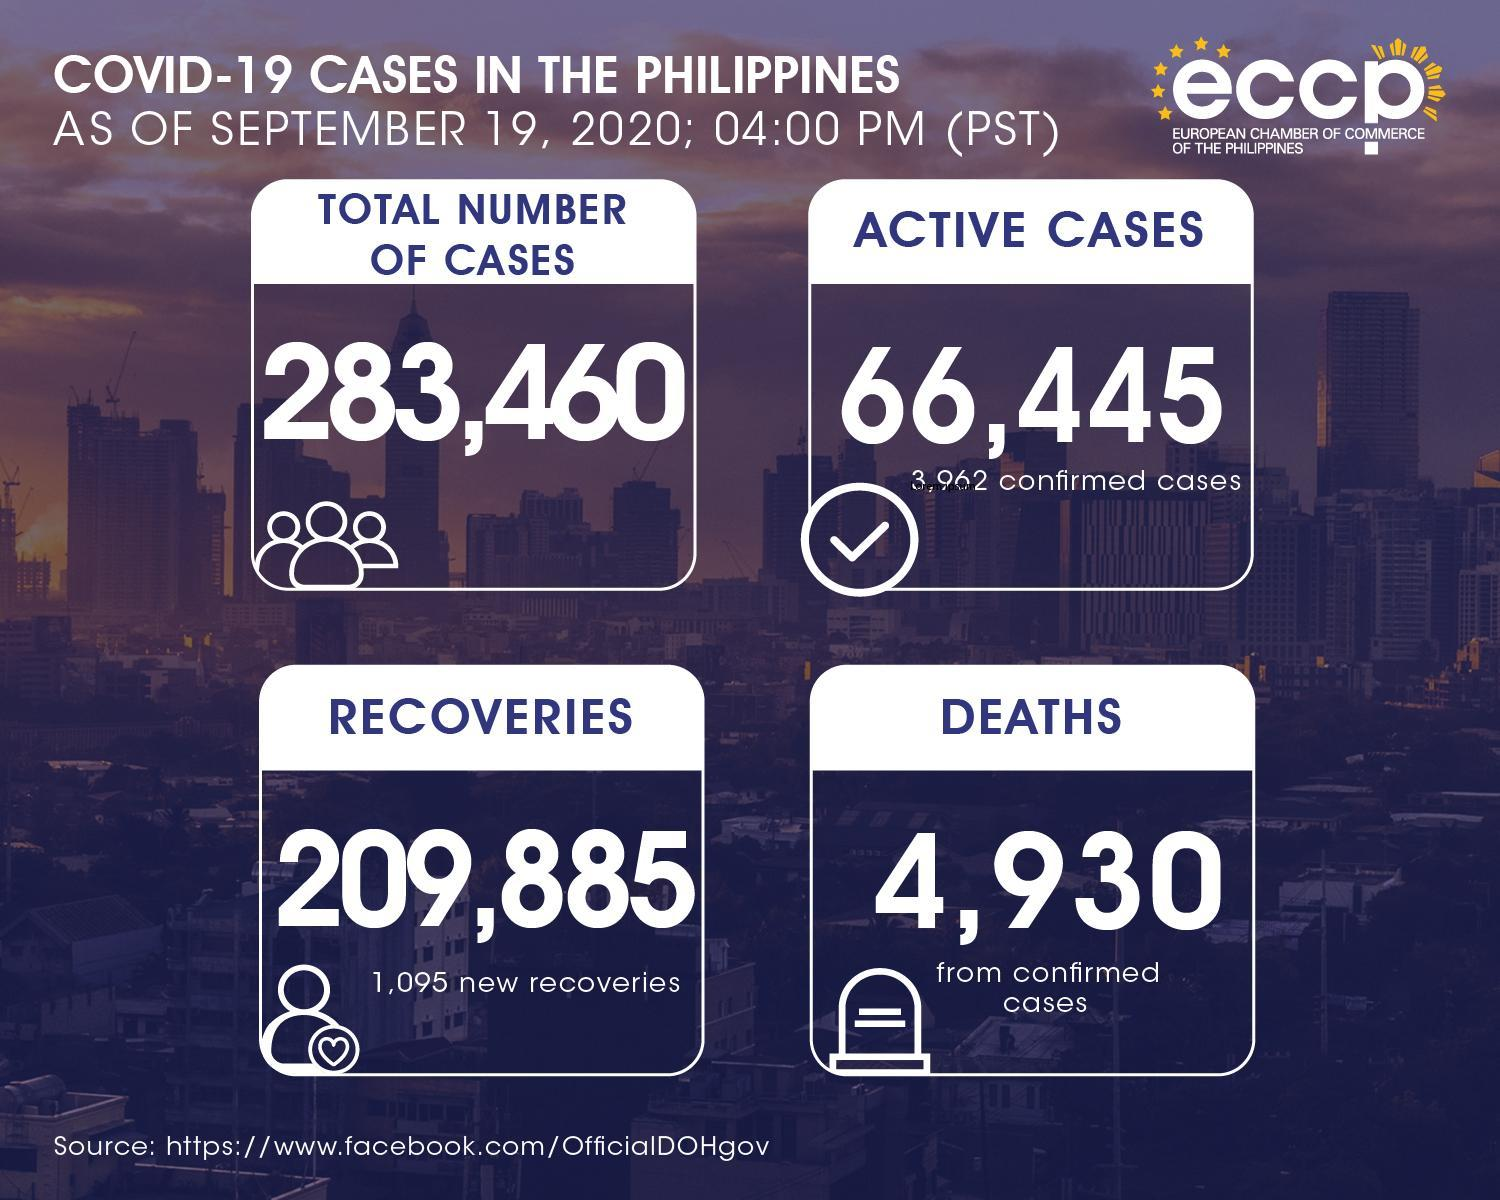What is the number of new recoveries from COVID-19 in the Phillippines as of september 19, 2020?
Answer the question with a short phrase. 1,095 What is the total number of COVID-19 cases in the Phillippines as of september 19, 2020? 283,460 What is the total number of COVID-19 deaths in the Phillippines as of september 19, 2020? 4,930 What is the total number of active  COVID-19 cases in the Phillippines as of september 19, 2020? 66,445 